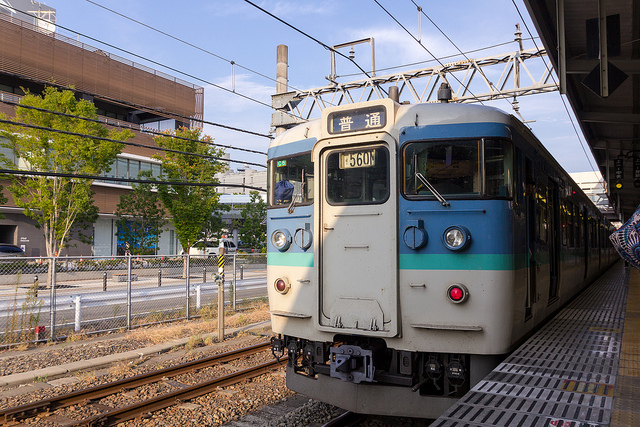Identify the text contained in this image. 560 